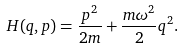Convert formula to latex. <formula><loc_0><loc_0><loc_500><loc_500>H ( q , p ) = \frac { p ^ { 2 } } { 2 m } + \frac { m \omega ^ { 2 } } { 2 } q ^ { 2 } .</formula> 